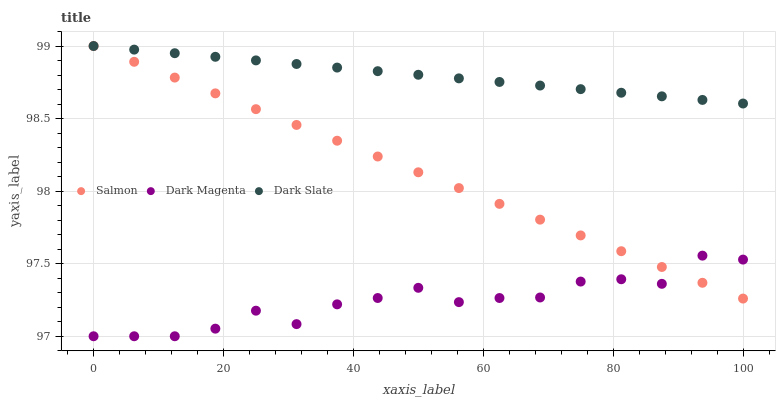Does Dark Magenta have the minimum area under the curve?
Answer yes or no. Yes. Does Dark Slate have the maximum area under the curve?
Answer yes or no. Yes. Does Salmon have the minimum area under the curve?
Answer yes or no. No. Does Salmon have the maximum area under the curve?
Answer yes or no. No. Is Salmon the smoothest?
Answer yes or no. Yes. Is Dark Magenta the roughest?
Answer yes or no. Yes. Is Dark Magenta the smoothest?
Answer yes or no. No. Is Salmon the roughest?
Answer yes or no. No. Does Dark Magenta have the lowest value?
Answer yes or no. Yes. Does Salmon have the lowest value?
Answer yes or no. No. Does Salmon have the highest value?
Answer yes or no. Yes. Does Dark Magenta have the highest value?
Answer yes or no. No. Is Dark Magenta less than Dark Slate?
Answer yes or no. Yes. Is Dark Slate greater than Dark Magenta?
Answer yes or no. Yes. Does Dark Magenta intersect Salmon?
Answer yes or no. Yes. Is Dark Magenta less than Salmon?
Answer yes or no. No. Is Dark Magenta greater than Salmon?
Answer yes or no. No. Does Dark Magenta intersect Dark Slate?
Answer yes or no. No. 